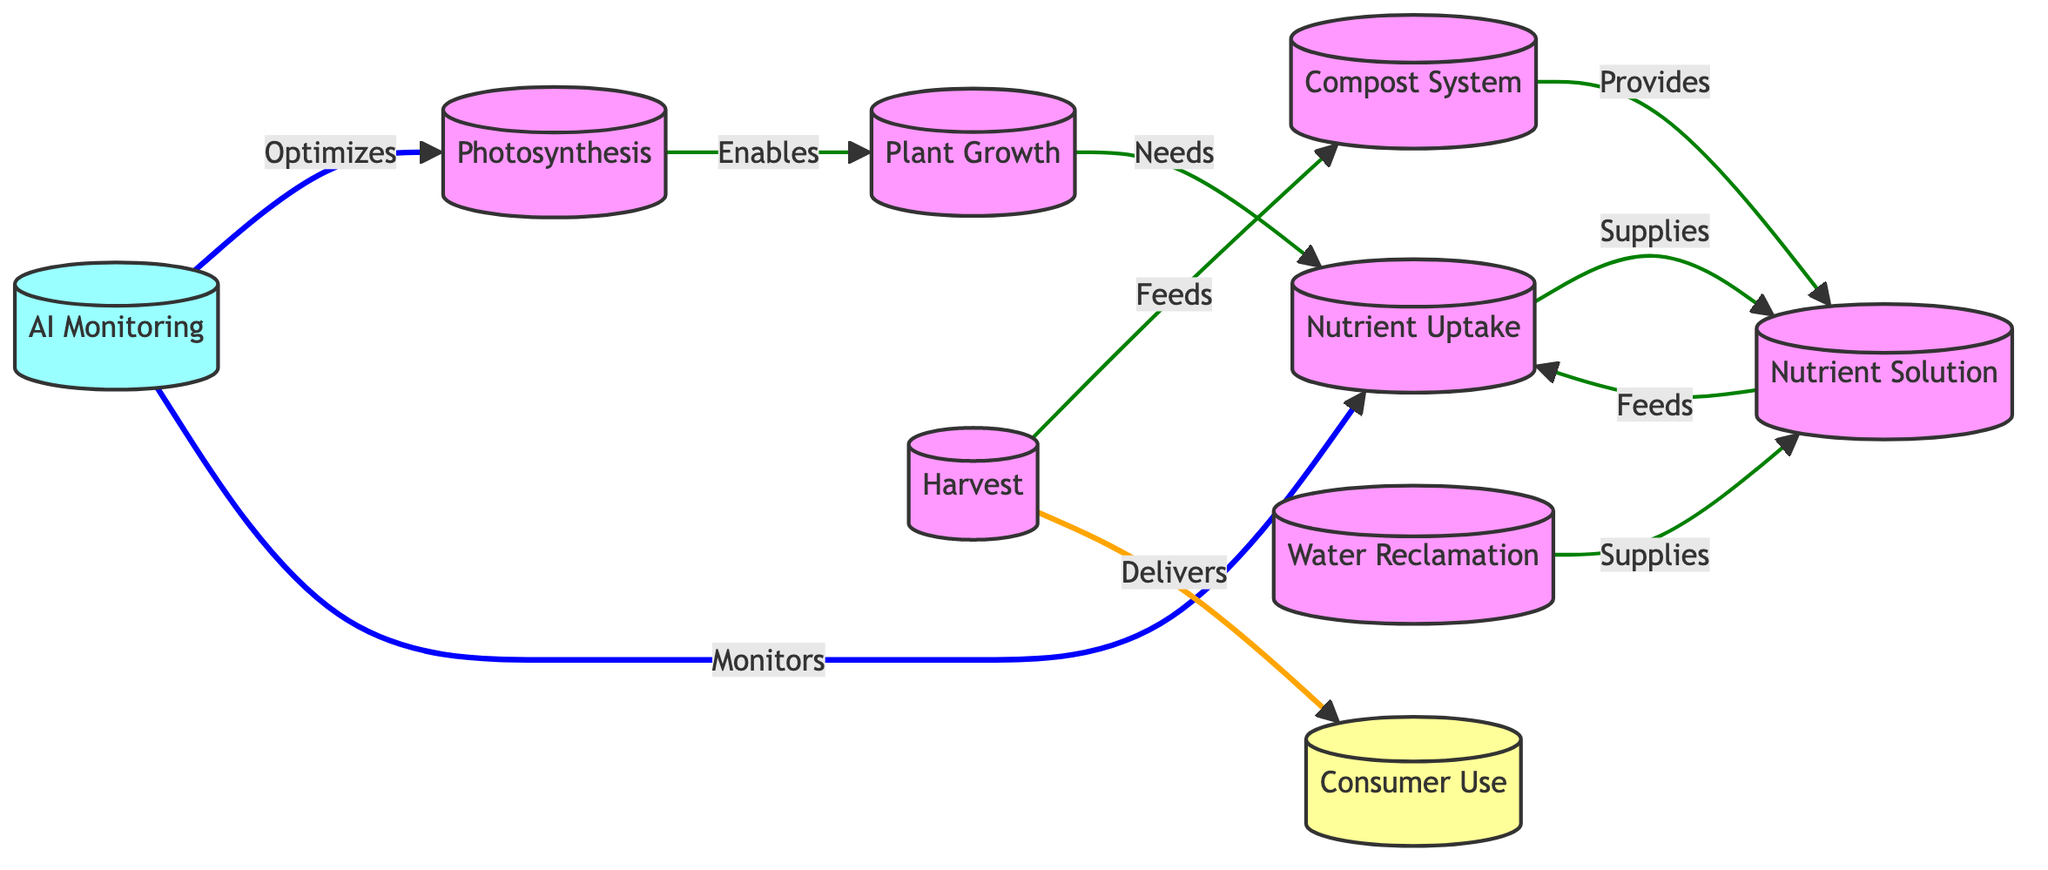What are the main components of the nutrient cycle shown in the diagram? The main components are Photosynthesis, Plant Growth, Nutrient Uptake, AI Monitoring, Compost System, Nutrient Solution, Water Reclamation, Harvest, and Consumer Use. These nodes are interconnected, representing a cycle focused on nutrient dynamics in agriculture.
Answer: Photosynthesis, Plant Growth, Nutrient Uptake, AI Monitoring, Compost System, Nutrient Solution, Water Reclamation, Harvest, Consumer Use How many nodes are present in the diagram? By counting each distinct node shown in the flowchart, we can identify that there are 9 nodes in total.
Answer: 9 What role does AI Monitoring play in the cycle? AI Monitoring optimizes the Photosynthesis process and monitors Nutrient Uptake, ensuring that both processes align with optimal conditions for plant growth. This role is critical in enhancing efficiency and productivity.
Answer: Optimizes, Monitors Which node directly supplies the Nutrient Solution? The Nutrient Solution is supplied by two nodes: Nutrient Uptake and Water Reclamation. Both provide essential nutrients to support plant growth.
Answer: Nutrient Uptake, Water Reclamation What is the connection between Plant Growth and Nutrient Uptake? The connection is that Plant Growth needs Nutrient Uptake, which provides the required nutrients essential for the plants' development and health. This shows a dependency relationship where one supports the other directly.
Answer: Needs How does the Compost System contribute to the nutrient cycle? The Compost System provides nutrients to the Nutrient Solution, which is an integral part of the cycle. By converting organic waste back into usable nutrients, it plays a vital role in sustaining the nutrient supply for plant growth.
Answer: Provides What happens to the Harvest in the cycle? The Harvest feeds into the Compost System and delivers to the Consumer Use, indicating that the output of the growth process contributes to both waste recycling and food distribution.
Answer: Feeds, Delivers Which connections are represented in blue? The blue connections in the diagram indicate the flow between Nutrient Uptake and AI Monitoring, symbolizing the critical feedback loop for monitoring nutrient levels and optimizing plant health.
Answer: Nutrient Uptake, AI Monitoring How do Nutrient Solution and Water Reclamation interact? Nutrient Solution is supplied by both Nutrient Uptake and Water Reclamation, showing that they work together to maintain the nutrient supply essential for plant growth. This interaction highlights the collaborative nature of resource management in the system.
Answer: Supplies 